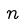Convert formula to latex. <formula><loc_0><loc_0><loc_500><loc_500>n</formula> 